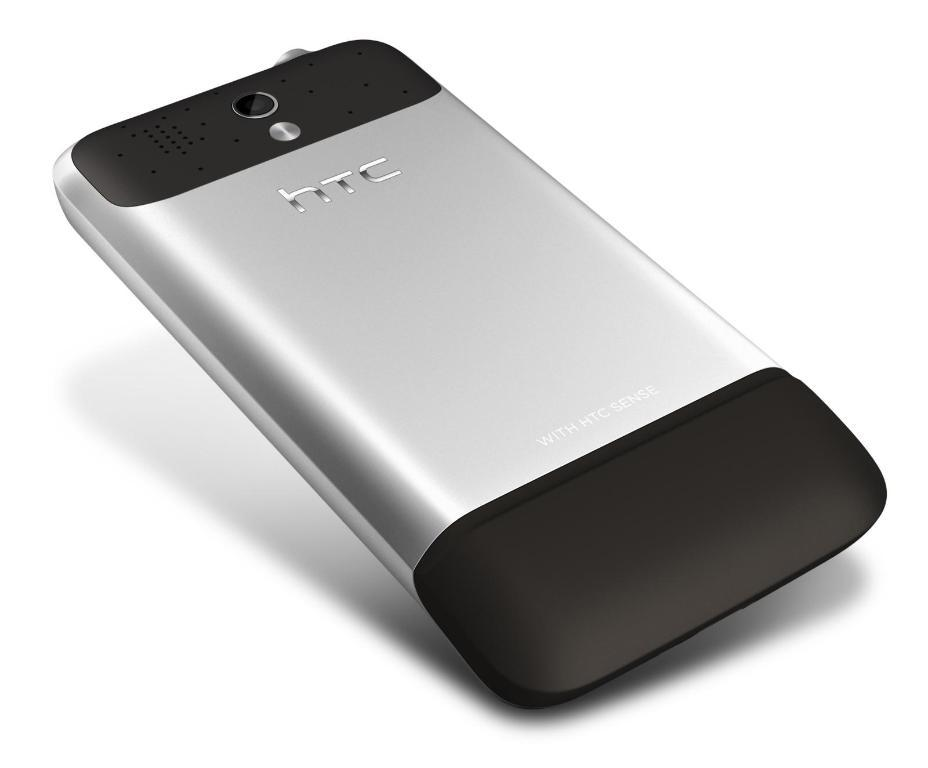<image>
Share a concise interpretation of the image provided. A htc black and silver smart phone facing down. 